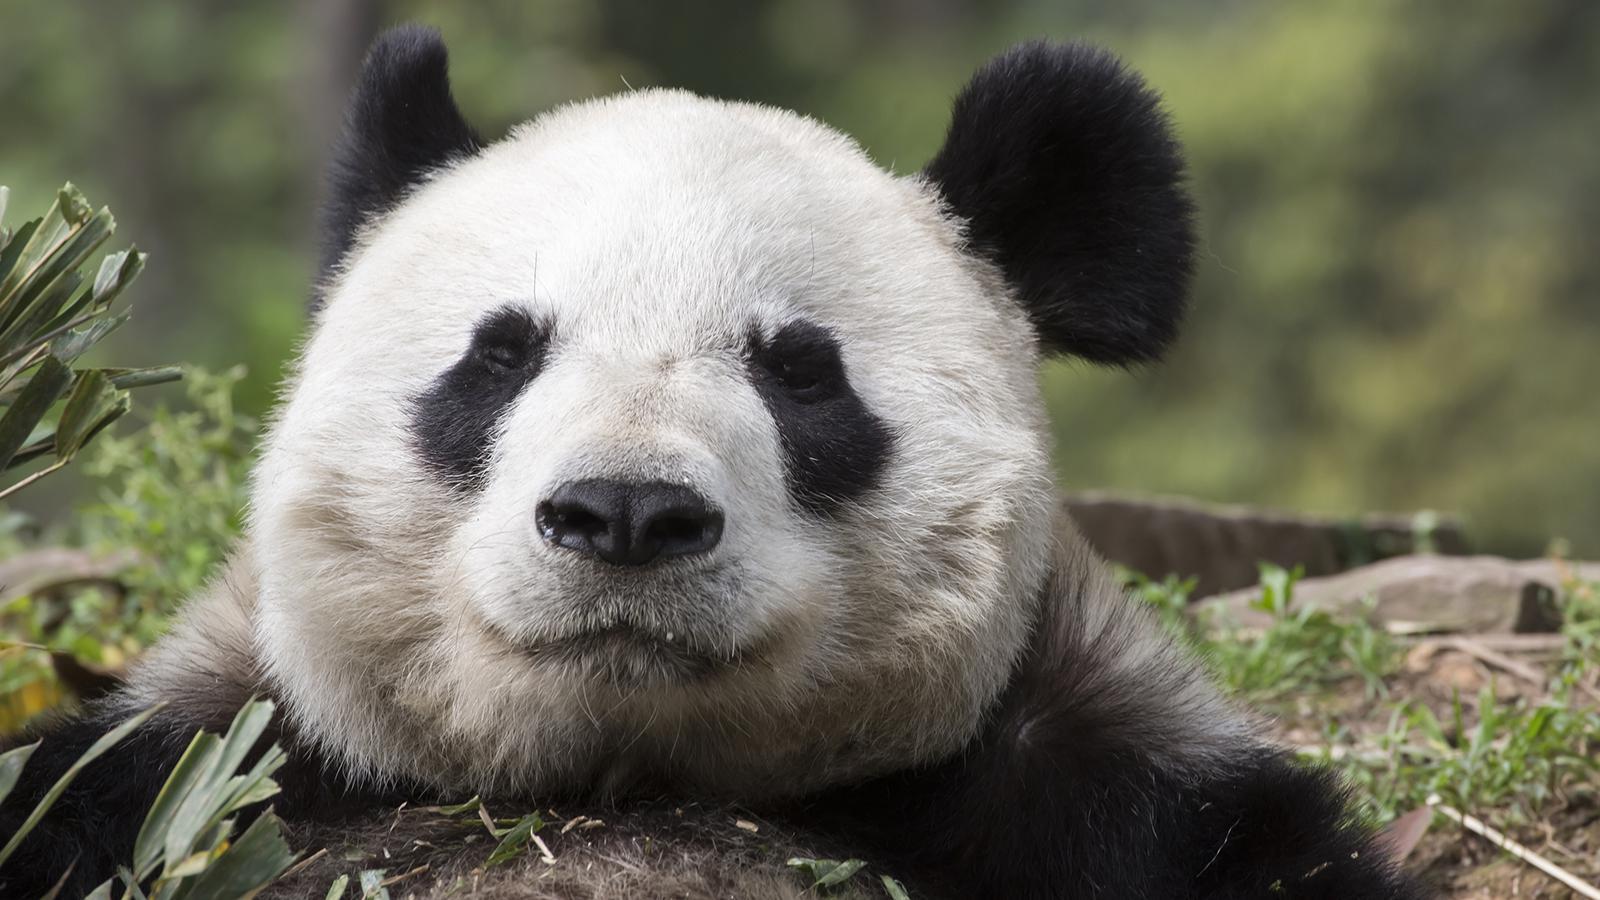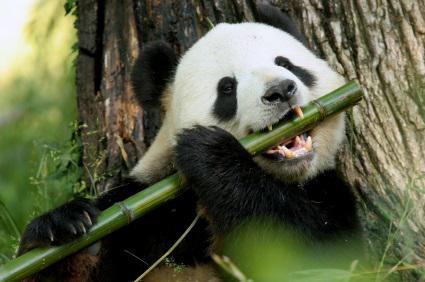The first image is the image on the left, the second image is the image on the right. Evaluate the accuracy of this statement regarding the images: "The panda in the left image has a bamboo stock in their hand.". Is it true? Answer yes or no. No. The first image is the image on the left, the second image is the image on the right. Assess this claim about the two images: "The lefthand image contains one panda, which is holding a green stalk.". Correct or not? Answer yes or no. No. 